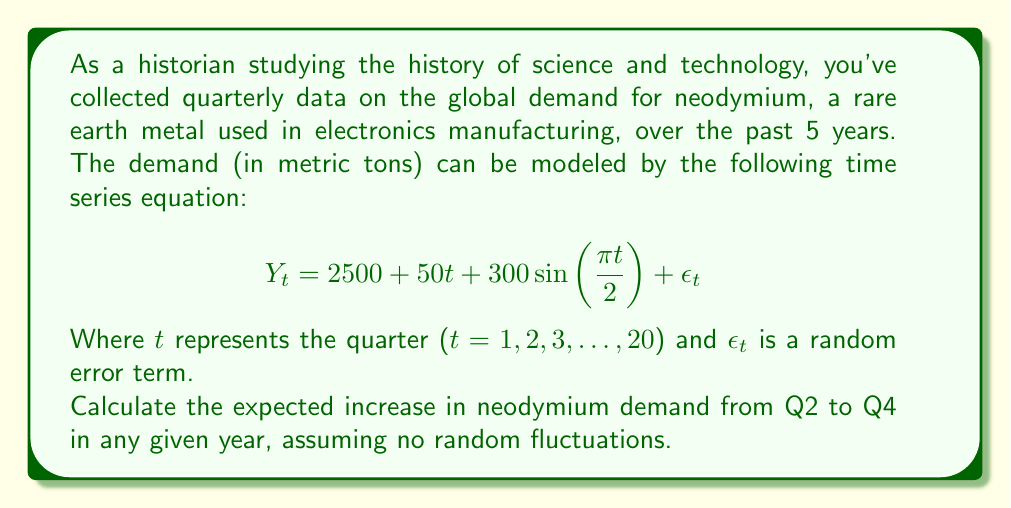Could you help me with this problem? To solve this problem, we need to follow these steps:

1) First, let's understand the components of the time series equation:
   - $2500$ is the baseline demand
   - $50t$ represents the linear trend
   - $300\sin(\frac{\pi t}{2})$ is the seasonal component
   - $\epsilon_t$ is the random error term (which we'll ignore as per the question)

2) We need to calculate the difference between Q4 and Q2 in any year. Let's consider a generic year where:
   - Q2 is represented by $t$
   - Q4 is represented by $t+2$

3) For Q2 (ignoring the error term):
   $$Y_t = 2500 + 50t + 300\sin(\frac{\pi t}{2})$$

4) For Q4:
   $$Y_{t+2} = 2500 + 50(t+2) + 300\sin(\frac{\pi (t+2)}{2})$$

5) The difference is:
   $$Y_{t+2} - Y_t = [2500 + 50(t+2) + 300\sin(\frac{\pi (t+2)}{2})] - [2500 + 50t + 300\sin(\frac{\pi t}{2})]$$

6) Simplify:
   $$Y_{t+2} - Y_t = 100 + 300[\sin(\frac{\pi (t+2)}{2}) - \sin(\frac{\pi t}{2})]$$

7) Recall the trigonometric identity:
   $$\sin A - \sin B = 2 \cos(\frac{A+B}{2}) \sin(\frac{A-B}{2})$$

8) Apply this to our equation:
   $$Y_{t+2} - Y_t = 100 + 300[2 \cos(\frac{\pi(t+2)+\pi t}{4}) \sin(\frac{\pi(t+2)-\pi t}{4})]$$
   $$= 100 + 600 \cos(\frac{\pi(2t+2)}{4}) \sin(\frac{\pi}{2})$$
   $$= 100 + 600 \cos(\frac{\pi t}{2}+\frac{\pi}{4})$$

9) This is the general formula for the difference between Q4 and Q2 in any year. 
   However, note that $\cos(\frac{\pi t}{2}+\frac{\pi}{4})$ will always equal $-\frac{\sqrt{2}}{2}$ for Q2 in any year.

10) Therefore, the final result is:
    $$Y_{t+2} - Y_t = 100 + 600(-\frac{\sqrt{2}}{2}) = 100 - 300\sqrt{2}$$
Answer: The expected increase in neodymium demand from Q2 to Q4 in any given year, assuming no random fluctuations, is $100 - 300\sqrt{2}$ metric tons, or approximately -323.94 metric tons. This negative value indicates an expected decrease in demand from Q2 to Q4. 